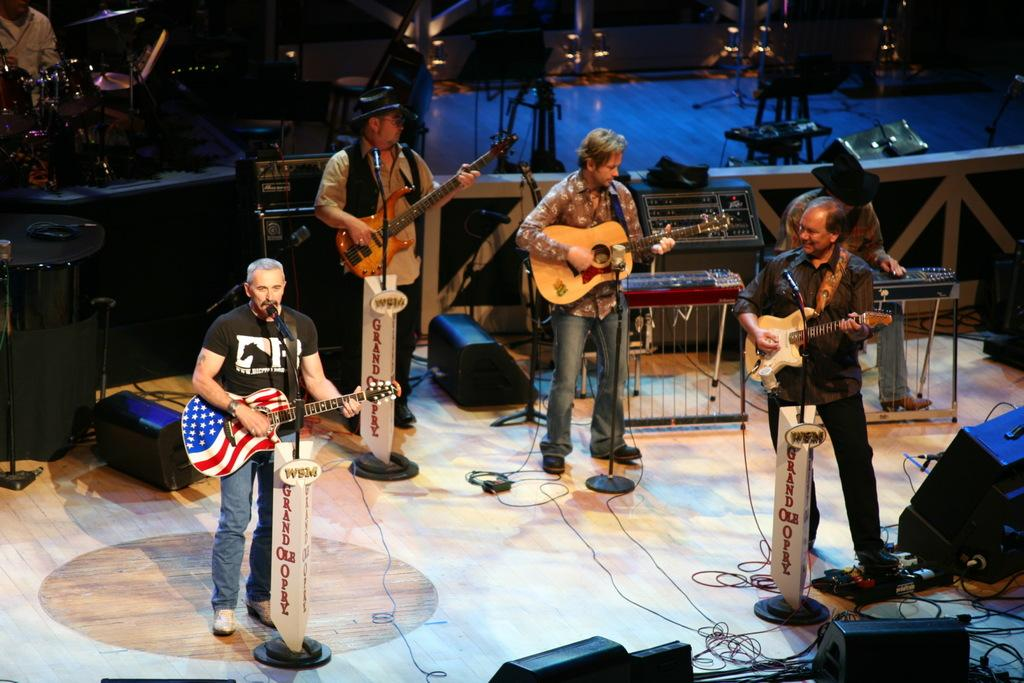How many people are in the image? There are six persons in the image. What are the six persons doing in the image? Each of the six persons is playing a musical instrument. What type of pig can be seen playing a musical instrument in the image? There is no pig present in the image, and therefore no such activity can be observed. 